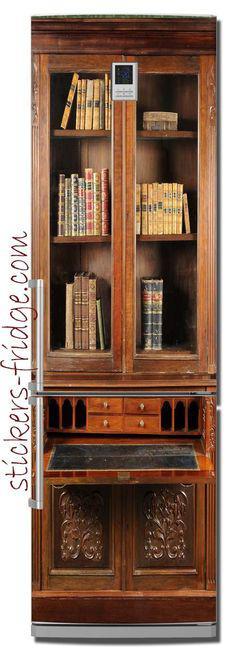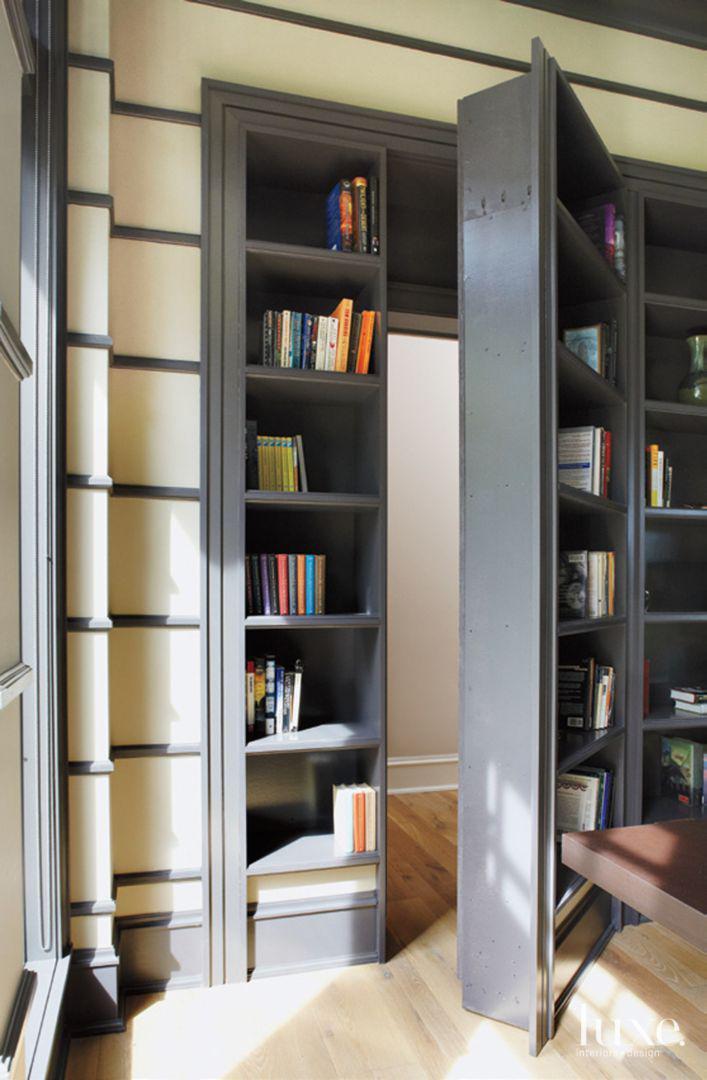The first image is the image on the left, the second image is the image on the right. Analyze the images presented: Is the assertion "A bookcase in one image has upper glass doors with panes, over a solid lower section." valid? Answer yes or no. No. 